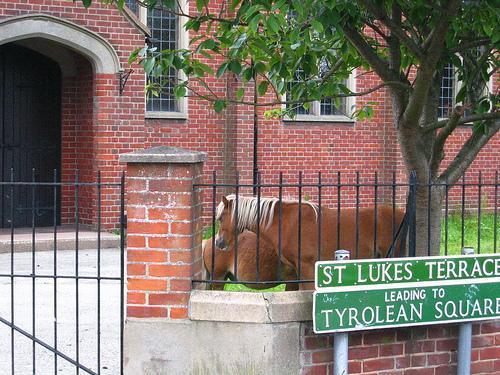How many horse do you see?
Give a very brief answer. 2. 